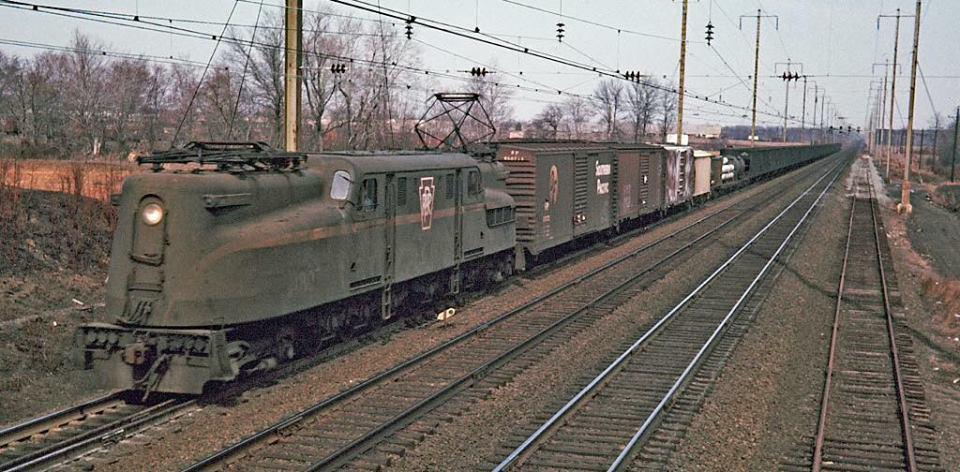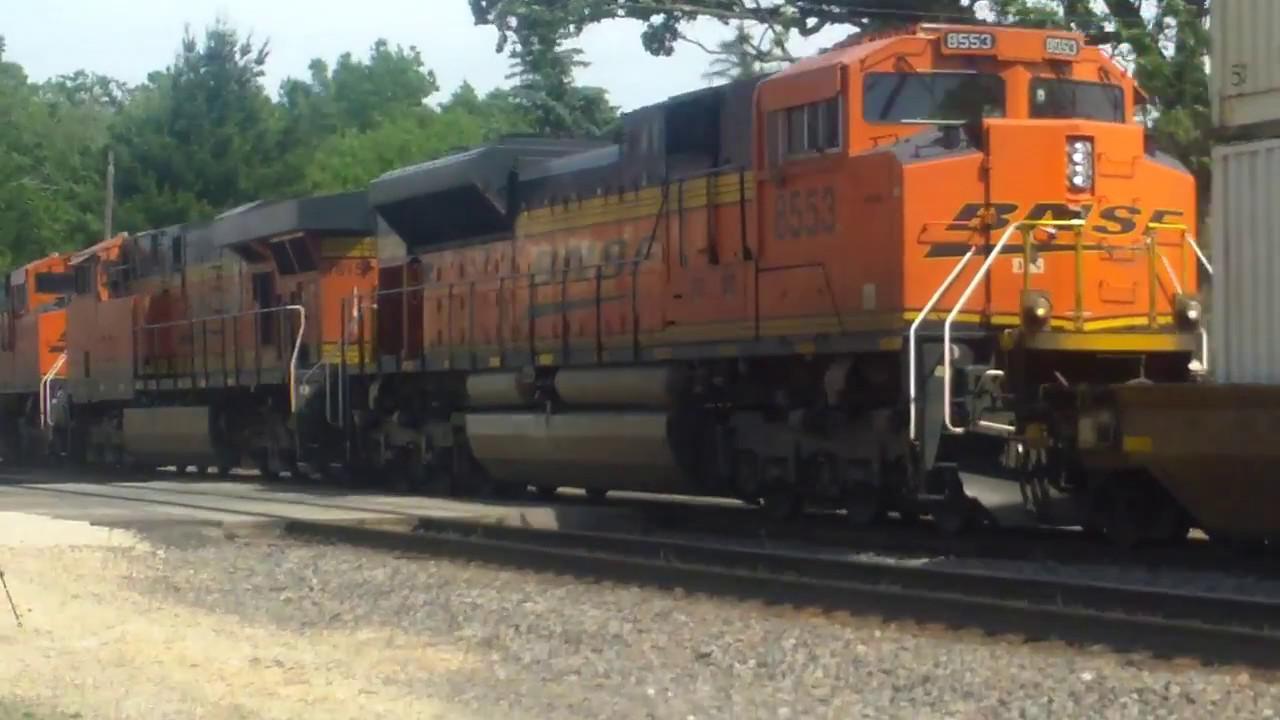The first image is the image on the left, the second image is the image on the right. For the images displayed, is the sentence "At least one train has a visibly sloped front with a band of solid color around the windshield." factually correct? Answer yes or no. No. The first image is the image on the left, the second image is the image on the right. Analyze the images presented: Is the assertion "The train in the image to the right features a fair amount of green paint." valid? Answer yes or no. No. 